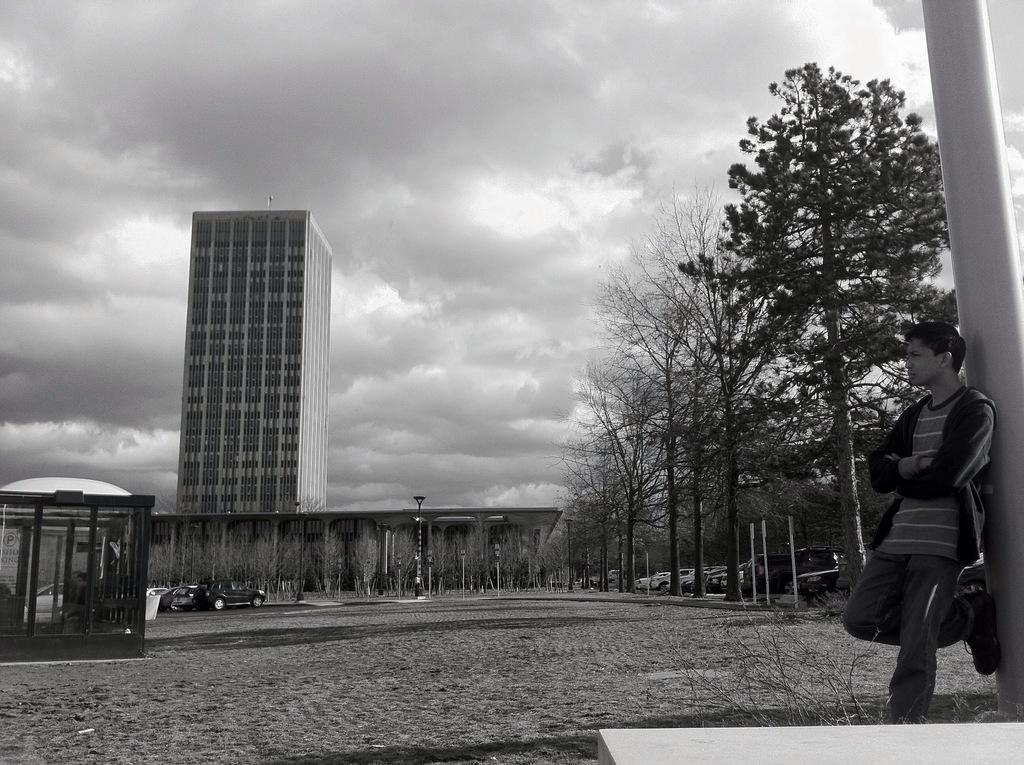What is located in the foreground of the image? There is a person, a pole, and a shed in the foreground of the image. What can be seen in the background of the image? There are buildings, trees, vehicles on the road, and the sky visible in the background of the image. How might the image have been captured? The image may have been taken from the ground level. What type of learning can be observed in the image? There is no learning activity depicted in the image. Can you see an owl in the image? There is no owl present in the image. 